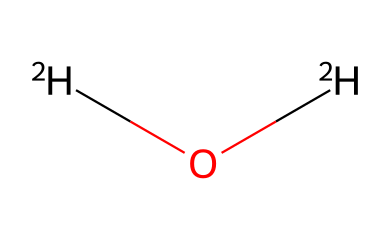What is the molecular formula of this compound? The SMILES representation shows two deuterium atoms (represented as [2H]) and one oxygen atom (O). Therefore, the molecular formula is D2O, where D stands for deuterium.
Answer: D2O How many hydrogen isotopes are in this chemical? The structure includes two deuterium atoms, which are isotopes of hydrogen. Counting the number of [2H] shows there are two isotopes present.
Answer: 2 What type of water is represented by this chemical? The presence of deuterium instead of regular hydrogen indicates that this is heavy water, which is specifically characterized by deuterium.
Answer: heavy water What is the primary use of this compound? Deuterium oxide is primarily used in nuclear reactors as a moderator to slow down neutrons, facilitating nuclear reactions.
Answer: nuclear reactors Is the viscosity of this compound higher or lower compared to regular water? Heavy water has a higher viscosity than regular water due to the presence of deuterium, which affects the overall molecular interactions.
Answer: higher How does the presence of isotopes in this compound affect its chemical properties? The presence of deuterium isotopes alters the bond lengths and bond strengths compared to regular water, which can influence properties like boiling point and reactivity.
Answer: alters properties 